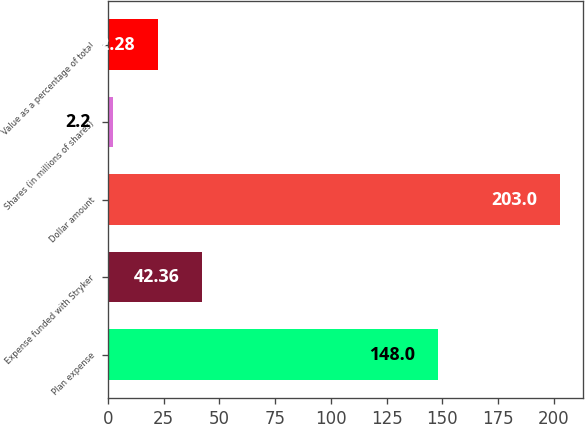Convert chart to OTSL. <chart><loc_0><loc_0><loc_500><loc_500><bar_chart><fcel>Plan expense<fcel>Expense funded with Stryker<fcel>Dollar amount<fcel>Shares (in millions of shares)<fcel>Value as a percentage of total<nl><fcel>148<fcel>42.36<fcel>203<fcel>2.2<fcel>22.28<nl></chart> 